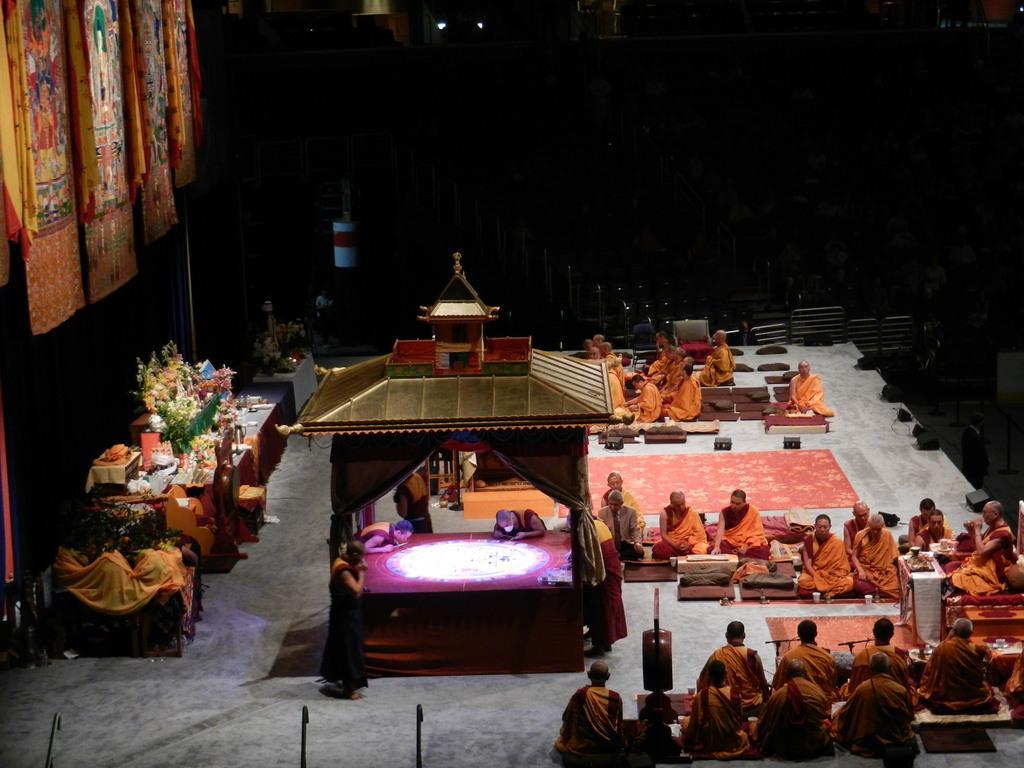How would you summarize this image in a sentence or two? In this picture we can see a group of people sitting on the floor, cloths, shed, some objects and in the background it is dark. 